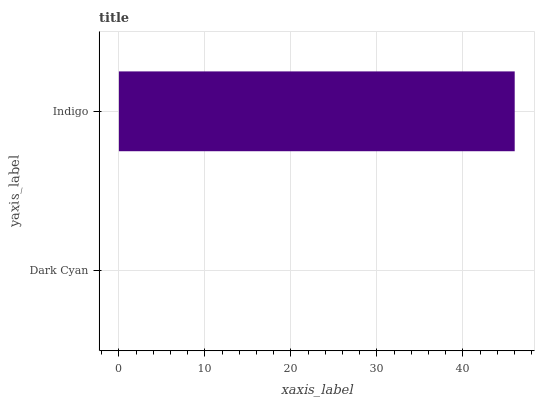Is Dark Cyan the minimum?
Answer yes or no. Yes. Is Indigo the maximum?
Answer yes or no. Yes. Is Indigo the minimum?
Answer yes or no. No. Is Indigo greater than Dark Cyan?
Answer yes or no. Yes. Is Dark Cyan less than Indigo?
Answer yes or no. Yes. Is Dark Cyan greater than Indigo?
Answer yes or no. No. Is Indigo less than Dark Cyan?
Answer yes or no. No. Is Indigo the high median?
Answer yes or no. Yes. Is Dark Cyan the low median?
Answer yes or no. Yes. Is Dark Cyan the high median?
Answer yes or no. No. Is Indigo the low median?
Answer yes or no. No. 